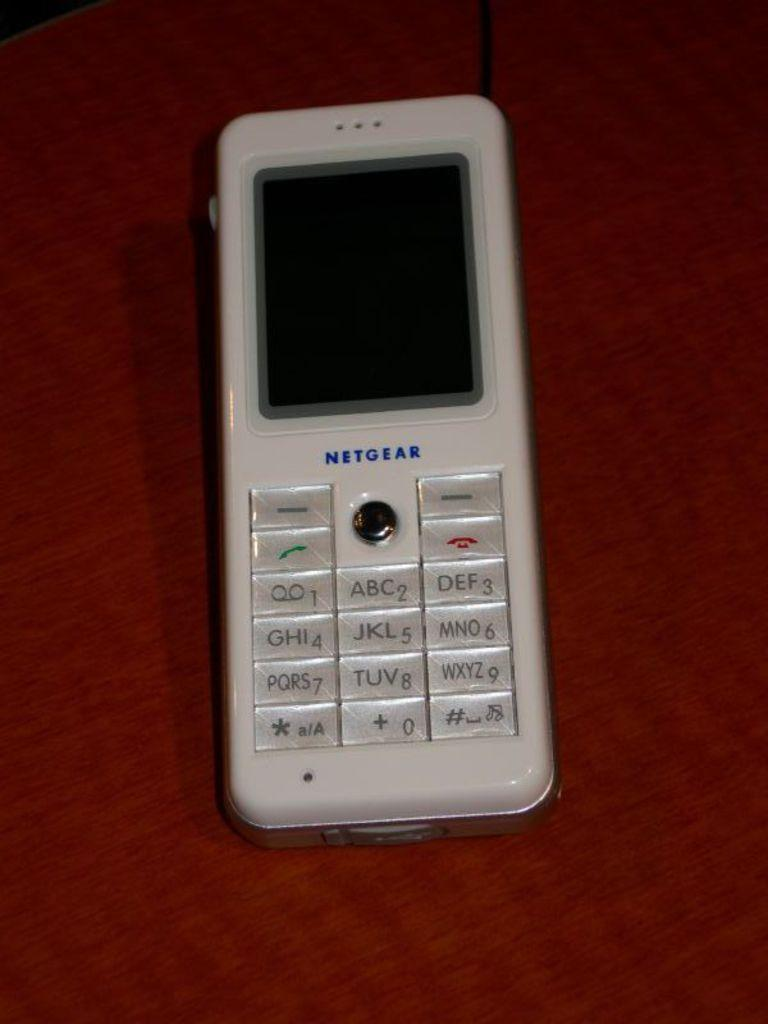Provide a one-sentence caption for the provided image. The old white phone sitting on the table is a Netgear phone. 